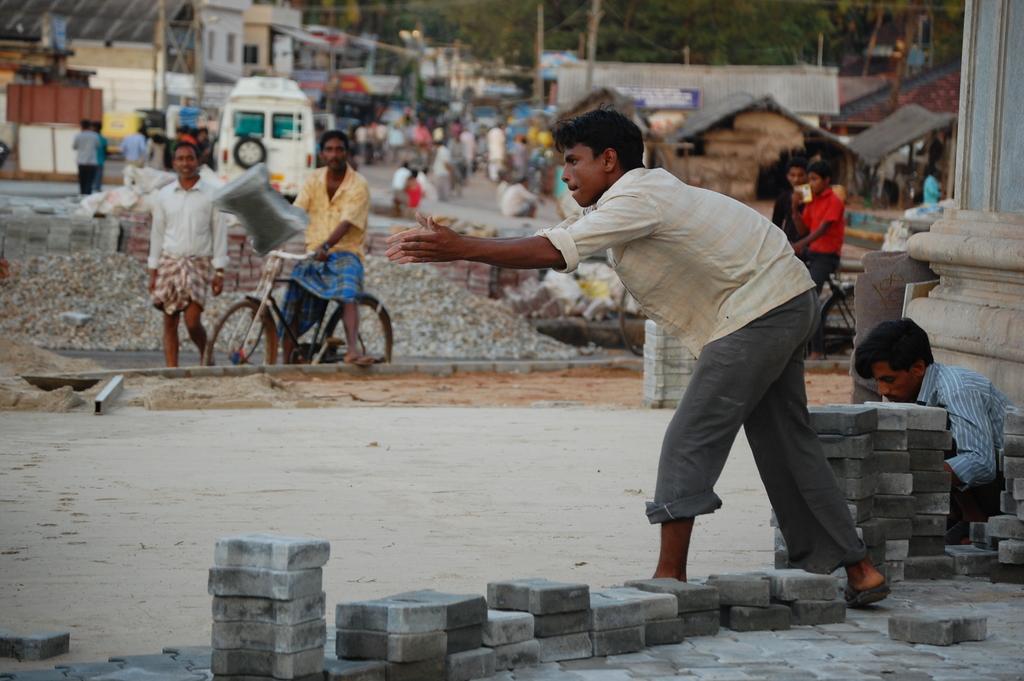Please provide a concise description of this image. In this image I can see group of people, some are standing and some are walking. In front the person is sitting on the bi-cycle, background I can see few vehicles, buildings and few poles, and I can see trees in green color. 